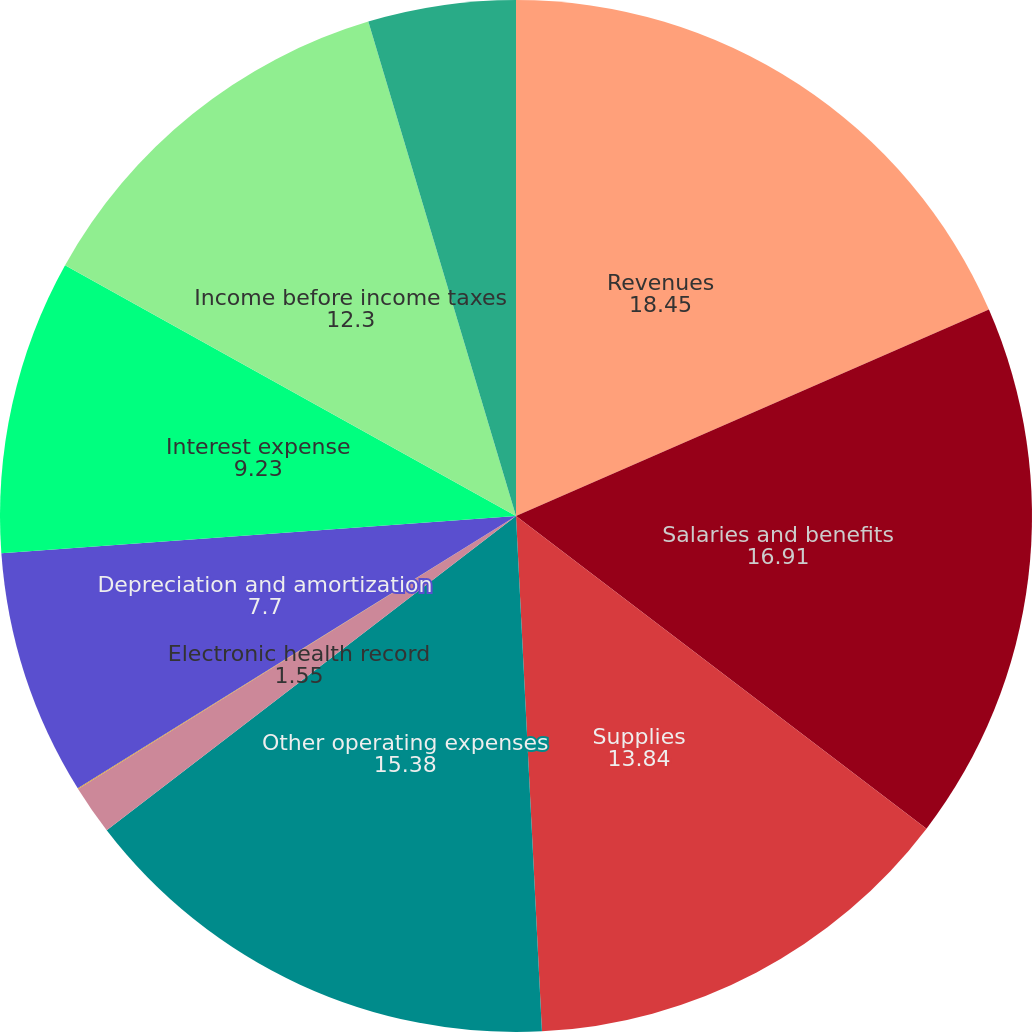Convert chart to OTSL. <chart><loc_0><loc_0><loc_500><loc_500><pie_chart><fcel>Revenues<fcel>Salaries and benefits<fcel>Supplies<fcel>Other operating expenses<fcel>Electronic health record<fcel>Equity in earnings of<fcel>Depreciation and amortization<fcel>Interest expense<fcel>Income before income taxes<fcel>Provision for income taxes<nl><fcel>18.45%<fcel>16.91%<fcel>13.84%<fcel>15.38%<fcel>1.55%<fcel>0.02%<fcel>7.7%<fcel>9.23%<fcel>12.3%<fcel>4.62%<nl></chart> 